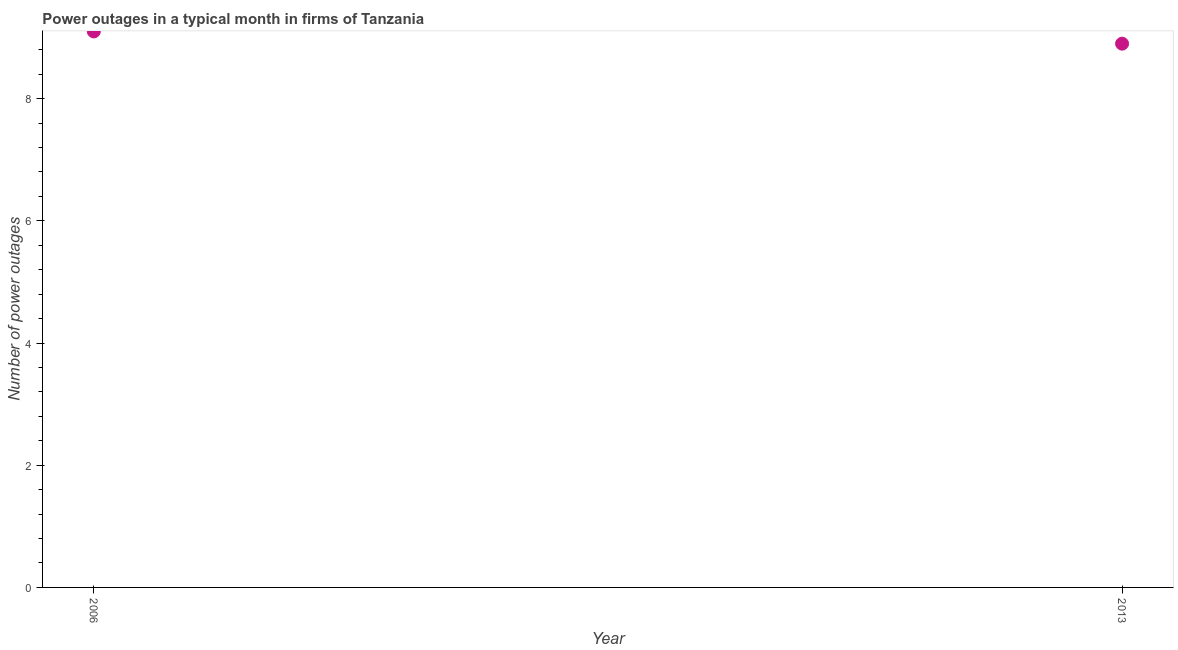What is the sum of the number of power outages?
Ensure brevity in your answer.  18. What is the difference between the number of power outages in 2006 and 2013?
Keep it short and to the point. 0.2. What is the median number of power outages?
Make the answer very short. 9. What is the ratio of the number of power outages in 2006 to that in 2013?
Offer a terse response. 1.02. In how many years, is the number of power outages greater than the average number of power outages taken over all years?
Your response must be concise. 1. How many dotlines are there?
Your response must be concise. 1. Does the graph contain any zero values?
Ensure brevity in your answer.  No. Does the graph contain grids?
Make the answer very short. No. What is the title of the graph?
Provide a succinct answer. Power outages in a typical month in firms of Tanzania. What is the label or title of the Y-axis?
Provide a short and direct response. Number of power outages. What is the Number of power outages in 2013?
Ensure brevity in your answer.  8.9. 